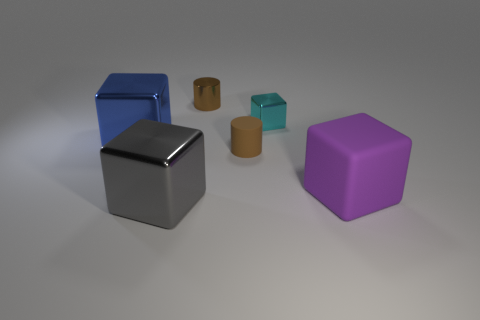Subtract all large blue metal cubes. How many cubes are left? 3 Subtract all cyan blocks. How many blocks are left? 3 Subtract 1 cyan blocks. How many objects are left? 5 Subtract all cylinders. How many objects are left? 4 Subtract 1 cylinders. How many cylinders are left? 1 Subtract all gray cubes. Subtract all yellow cylinders. How many cubes are left? 3 Subtract all brown cubes. How many purple cylinders are left? 0 Subtract all tiny gray things. Subtract all cyan shiny objects. How many objects are left? 5 Add 6 metal cylinders. How many metal cylinders are left? 7 Add 5 big purple rubber spheres. How many big purple rubber spheres exist? 5 